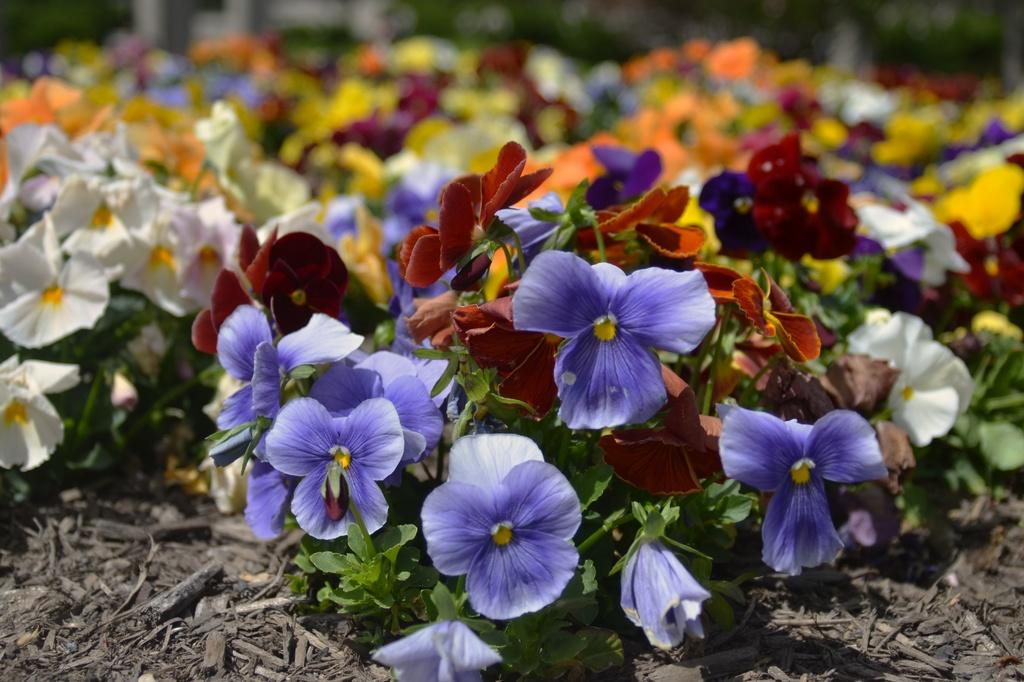What types of plants are visible in the image? There are different types of flowers in the image. What can be seen at the bottom of the image? There is some scrap at the bottom of the image. What action is the bee performing in the image? There is no bee present in the image, so it cannot be determined what action the bee might be performing. 